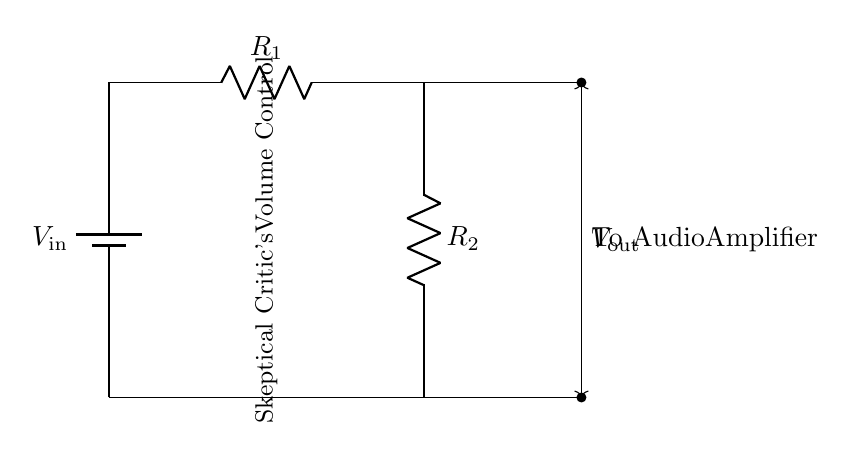What is the input voltage for this circuit? The input voltage is represented by the label \( V_\text{in} \) next to the battery in the circuit diagram.
Answer: V_in What are the two resistances in this circuit? The two resistances are represented by the labels \( R_1 \) and \( R_2 \), which are components in the circuit shown in series with each other.
Answer: R1, R2 What is the purpose of this circuit? The circuit is designed to adjust the audio levels, as indicated by the label "Skeptical Critic's Volume Control."
Answer: Audio level adjustment How is the output voltage represented? The output voltage is indicated by the label \( V_\text{out} \) which is placed along the vertical line connecting the two outputs from the resistors.
Answer: V_out Why would one use a voltage divider in an audio system? A voltage divider is commonly used to scale down the voltage to a usable level for the audio amplifier, ensuring optimal performance without distortion.
Answer: To scale voltage What is the relationship between the resistors and \( V_\text{out} \)? The output voltage \( V_\text{out} \) is determined by the values of resistors \( R_1 \) and \( R_2 \), following the voltage divider rule: \( V_\text{out} = V_\text{in} \times \frac{R_2}{R_1 + R_2} \).
Answer: Voltage divider rule 